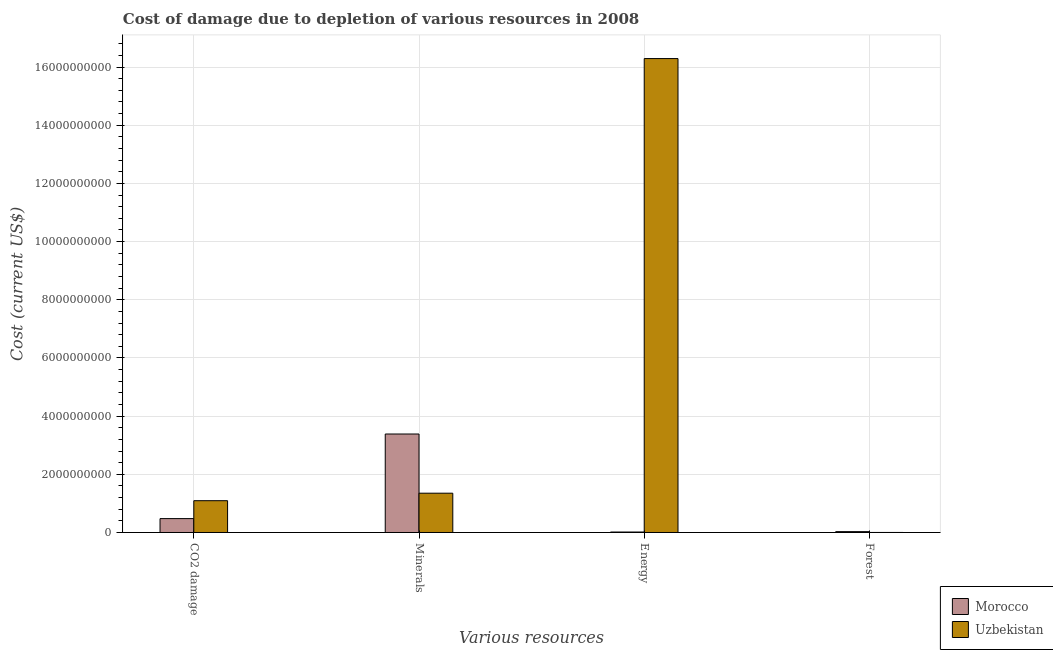How many different coloured bars are there?
Make the answer very short. 2. How many groups of bars are there?
Offer a very short reply. 4. How many bars are there on the 4th tick from the left?
Ensure brevity in your answer.  2. How many bars are there on the 1st tick from the right?
Provide a short and direct response. 2. What is the label of the 1st group of bars from the left?
Provide a succinct answer. CO2 damage. What is the cost of damage due to depletion of forests in Uzbekistan?
Make the answer very short. 8.58e+05. Across all countries, what is the maximum cost of damage due to depletion of forests?
Offer a very short reply. 2.91e+07. Across all countries, what is the minimum cost of damage due to depletion of coal?
Ensure brevity in your answer.  4.77e+08. In which country was the cost of damage due to depletion of coal maximum?
Ensure brevity in your answer.  Uzbekistan. In which country was the cost of damage due to depletion of forests minimum?
Provide a succinct answer. Uzbekistan. What is the total cost of damage due to depletion of coal in the graph?
Your answer should be very brief. 1.57e+09. What is the difference between the cost of damage due to depletion of coal in Uzbekistan and that in Morocco?
Provide a short and direct response. 6.15e+08. What is the difference between the cost of damage due to depletion of forests in Morocco and the cost of damage due to depletion of energy in Uzbekistan?
Keep it short and to the point. -1.63e+1. What is the average cost of damage due to depletion of minerals per country?
Make the answer very short. 2.37e+09. What is the difference between the cost of damage due to depletion of forests and cost of damage due to depletion of coal in Morocco?
Offer a very short reply. -4.48e+08. In how many countries, is the cost of damage due to depletion of minerals greater than 12800000000 US$?
Provide a succinct answer. 0. What is the ratio of the cost of damage due to depletion of coal in Morocco to that in Uzbekistan?
Your response must be concise. 0.44. What is the difference between the highest and the second highest cost of damage due to depletion of minerals?
Provide a succinct answer. 2.03e+09. What is the difference between the highest and the lowest cost of damage due to depletion of coal?
Provide a succinct answer. 6.15e+08. In how many countries, is the cost of damage due to depletion of energy greater than the average cost of damage due to depletion of energy taken over all countries?
Provide a succinct answer. 1. Is the sum of the cost of damage due to depletion of energy in Morocco and Uzbekistan greater than the maximum cost of damage due to depletion of minerals across all countries?
Give a very brief answer. Yes. What does the 2nd bar from the left in Minerals represents?
Offer a very short reply. Uzbekistan. What does the 1st bar from the right in Minerals represents?
Give a very brief answer. Uzbekistan. Is it the case that in every country, the sum of the cost of damage due to depletion of coal and cost of damage due to depletion of minerals is greater than the cost of damage due to depletion of energy?
Provide a succinct answer. No. How many bars are there?
Keep it short and to the point. 8. How many countries are there in the graph?
Offer a terse response. 2. What is the difference between two consecutive major ticks on the Y-axis?
Offer a terse response. 2.00e+09. Does the graph contain grids?
Your response must be concise. Yes. Where does the legend appear in the graph?
Offer a terse response. Bottom right. How many legend labels are there?
Offer a terse response. 2. What is the title of the graph?
Provide a short and direct response. Cost of damage due to depletion of various resources in 2008 . Does "Nepal" appear as one of the legend labels in the graph?
Your answer should be compact. No. What is the label or title of the X-axis?
Offer a terse response. Various resources. What is the label or title of the Y-axis?
Make the answer very short. Cost (current US$). What is the Cost (current US$) in Morocco in CO2 damage?
Your response must be concise. 4.77e+08. What is the Cost (current US$) of Uzbekistan in CO2 damage?
Offer a very short reply. 1.09e+09. What is the Cost (current US$) in Morocco in Minerals?
Make the answer very short. 3.38e+09. What is the Cost (current US$) of Uzbekistan in Minerals?
Offer a very short reply. 1.35e+09. What is the Cost (current US$) of Morocco in Energy?
Your response must be concise. 1.57e+07. What is the Cost (current US$) of Uzbekistan in Energy?
Give a very brief answer. 1.63e+1. What is the Cost (current US$) in Morocco in Forest?
Ensure brevity in your answer.  2.91e+07. What is the Cost (current US$) of Uzbekistan in Forest?
Your answer should be compact. 8.58e+05. Across all Various resources, what is the maximum Cost (current US$) of Morocco?
Give a very brief answer. 3.38e+09. Across all Various resources, what is the maximum Cost (current US$) in Uzbekistan?
Your response must be concise. 1.63e+1. Across all Various resources, what is the minimum Cost (current US$) in Morocco?
Provide a short and direct response. 1.57e+07. Across all Various resources, what is the minimum Cost (current US$) in Uzbekistan?
Make the answer very short. 8.58e+05. What is the total Cost (current US$) in Morocco in the graph?
Give a very brief answer. 3.91e+09. What is the total Cost (current US$) in Uzbekistan in the graph?
Keep it short and to the point. 1.87e+1. What is the difference between the Cost (current US$) of Morocco in CO2 damage and that in Minerals?
Give a very brief answer. -2.91e+09. What is the difference between the Cost (current US$) in Uzbekistan in CO2 damage and that in Minerals?
Provide a succinct answer. -2.58e+08. What is the difference between the Cost (current US$) of Morocco in CO2 damage and that in Energy?
Give a very brief answer. 4.62e+08. What is the difference between the Cost (current US$) of Uzbekistan in CO2 damage and that in Energy?
Your response must be concise. -1.52e+1. What is the difference between the Cost (current US$) in Morocco in CO2 damage and that in Forest?
Your answer should be compact. 4.48e+08. What is the difference between the Cost (current US$) of Uzbekistan in CO2 damage and that in Forest?
Your response must be concise. 1.09e+09. What is the difference between the Cost (current US$) of Morocco in Minerals and that in Energy?
Ensure brevity in your answer.  3.37e+09. What is the difference between the Cost (current US$) in Uzbekistan in Minerals and that in Energy?
Ensure brevity in your answer.  -1.49e+1. What is the difference between the Cost (current US$) in Morocco in Minerals and that in Forest?
Offer a very short reply. 3.36e+09. What is the difference between the Cost (current US$) in Uzbekistan in Minerals and that in Forest?
Make the answer very short. 1.35e+09. What is the difference between the Cost (current US$) of Morocco in Energy and that in Forest?
Your answer should be compact. -1.34e+07. What is the difference between the Cost (current US$) of Uzbekistan in Energy and that in Forest?
Ensure brevity in your answer.  1.63e+1. What is the difference between the Cost (current US$) in Morocco in CO2 damage and the Cost (current US$) in Uzbekistan in Minerals?
Provide a short and direct response. -8.73e+08. What is the difference between the Cost (current US$) in Morocco in CO2 damage and the Cost (current US$) in Uzbekistan in Energy?
Provide a succinct answer. -1.58e+1. What is the difference between the Cost (current US$) in Morocco in CO2 damage and the Cost (current US$) in Uzbekistan in Forest?
Ensure brevity in your answer.  4.77e+08. What is the difference between the Cost (current US$) in Morocco in Minerals and the Cost (current US$) in Uzbekistan in Energy?
Your answer should be compact. -1.29e+1. What is the difference between the Cost (current US$) in Morocco in Minerals and the Cost (current US$) in Uzbekistan in Forest?
Ensure brevity in your answer.  3.38e+09. What is the difference between the Cost (current US$) in Morocco in Energy and the Cost (current US$) in Uzbekistan in Forest?
Offer a very short reply. 1.49e+07. What is the average Cost (current US$) in Morocco per Various resources?
Ensure brevity in your answer.  9.77e+08. What is the average Cost (current US$) of Uzbekistan per Various resources?
Provide a succinct answer. 4.68e+09. What is the difference between the Cost (current US$) of Morocco and Cost (current US$) of Uzbekistan in CO2 damage?
Your answer should be compact. -6.15e+08. What is the difference between the Cost (current US$) of Morocco and Cost (current US$) of Uzbekistan in Minerals?
Your response must be concise. 2.03e+09. What is the difference between the Cost (current US$) in Morocco and Cost (current US$) in Uzbekistan in Energy?
Ensure brevity in your answer.  -1.63e+1. What is the difference between the Cost (current US$) in Morocco and Cost (current US$) in Uzbekistan in Forest?
Make the answer very short. 2.83e+07. What is the ratio of the Cost (current US$) in Morocco in CO2 damage to that in Minerals?
Provide a succinct answer. 0.14. What is the ratio of the Cost (current US$) in Uzbekistan in CO2 damage to that in Minerals?
Provide a short and direct response. 0.81. What is the ratio of the Cost (current US$) in Morocco in CO2 damage to that in Energy?
Provide a short and direct response. 30.33. What is the ratio of the Cost (current US$) of Uzbekistan in CO2 damage to that in Energy?
Your response must be concise. 0.07. What is the ratio of the Cost (current US$) of Morocco in CO2 damage to that in Forest?
Offer a terse response. 16.4. What is the ratio of the Cost (current US$) in Uzbekistan in CO2 damage to that in Forest?
Offer a terse response. 1274.1. What is the ratio of the Cost (current US$) in Morocco in Minerals to that in Energy?
Your answer should be very brief. 215.08. What is the ratio of the Cost (current US$) in Uzbekistan in Minerals to that in Energy?
Give a very brief answer. 0.08. What is the ratio of the Cost (current US$) of Morocco in Minerals to that in Forest?
Your answer should be compact. 116.26. What is the ratio of the Cost (current US$) in Uzbekistan in Minerals to that in Forest?
Your answer should be very brief. 1575.22. What is the ratio of the Cost (current US$) in Morocco in Energy to that in Forest?
Give a very brief answer. 0.54. What is the ratio of the Cost (current US$) of Uzbekistan in Energy to that in Forest?
Make the answer very short. 1.90e+04. What is the difference between the highest and the second highest Cost (current US$) of Morocco?
Your answer should be very brief. 2.91e+09. What is the difference between the highest and the second highest Cost (current US$) in Uzbekistan?
Give a very brief answer. 1.49e+1. What is the difference between the highest and the lowest Cost (current US$) of Morocco?
Your response must be concise. 3.37e+09. What is the difference between the highest and the lowest Cost (current US$) in Uzbekistan?
Your response must be concise. 1.63e+1. 